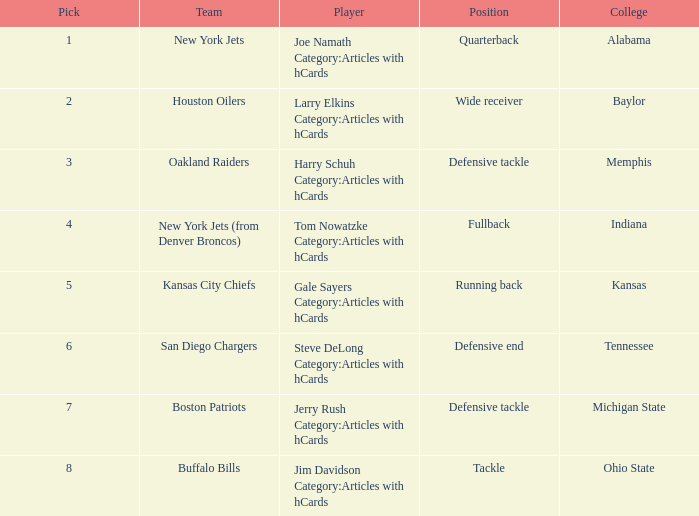What team has a position of running back and picked after 2? Kansas City Chiefs. 